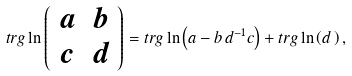<formula> <loc_0><loc_0><loc_500><loc_500>t r g \ln \left ( \begin{array} { c c } a & b \\ c & d \end{array} \right ) = t r g \ln \left ( a - b \, d ^ { - 1 } c \right ) + t r g \ln \left ( d \, \right ) ,</formula> 